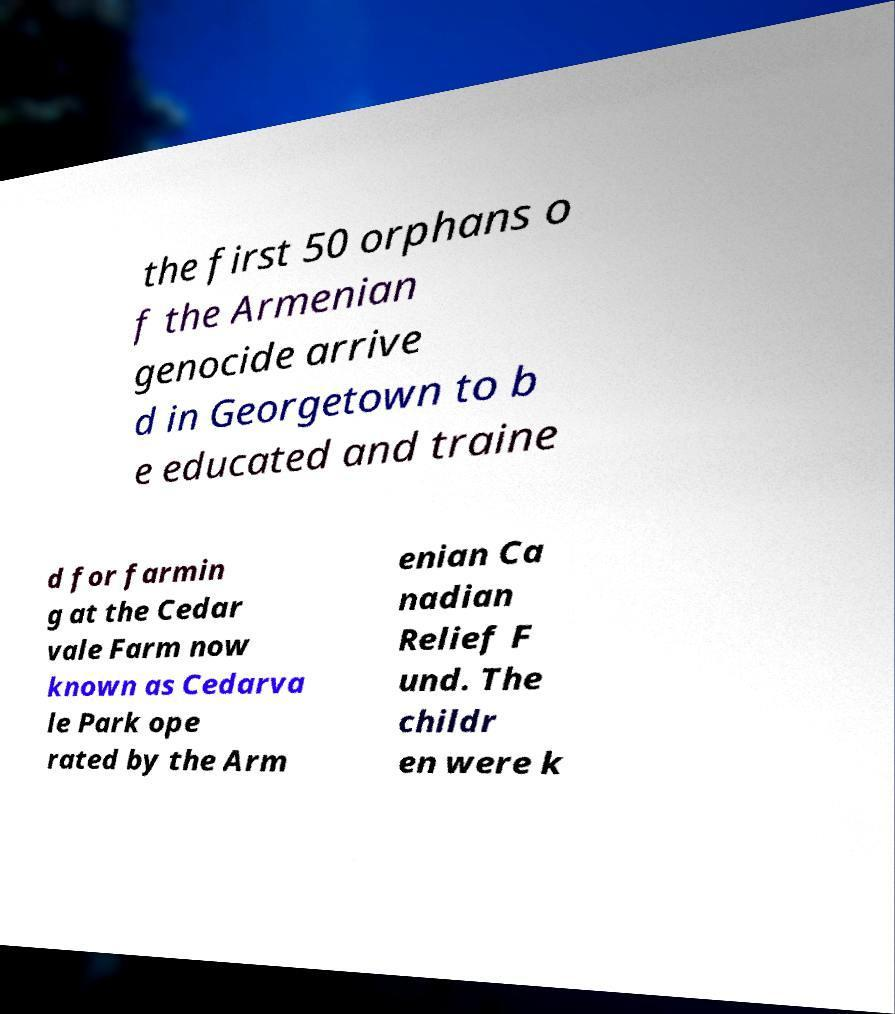Please identify and transcribe the text found in this image. the first 50 orphans o f the Armenian genocide arrive d in Georgetown to b e educated and traine d for farmin g at the Cedar vale Farm now known as Cedarva le Park ope rated by the Arm enian Ca nadian Relief F und. The childr en were k 